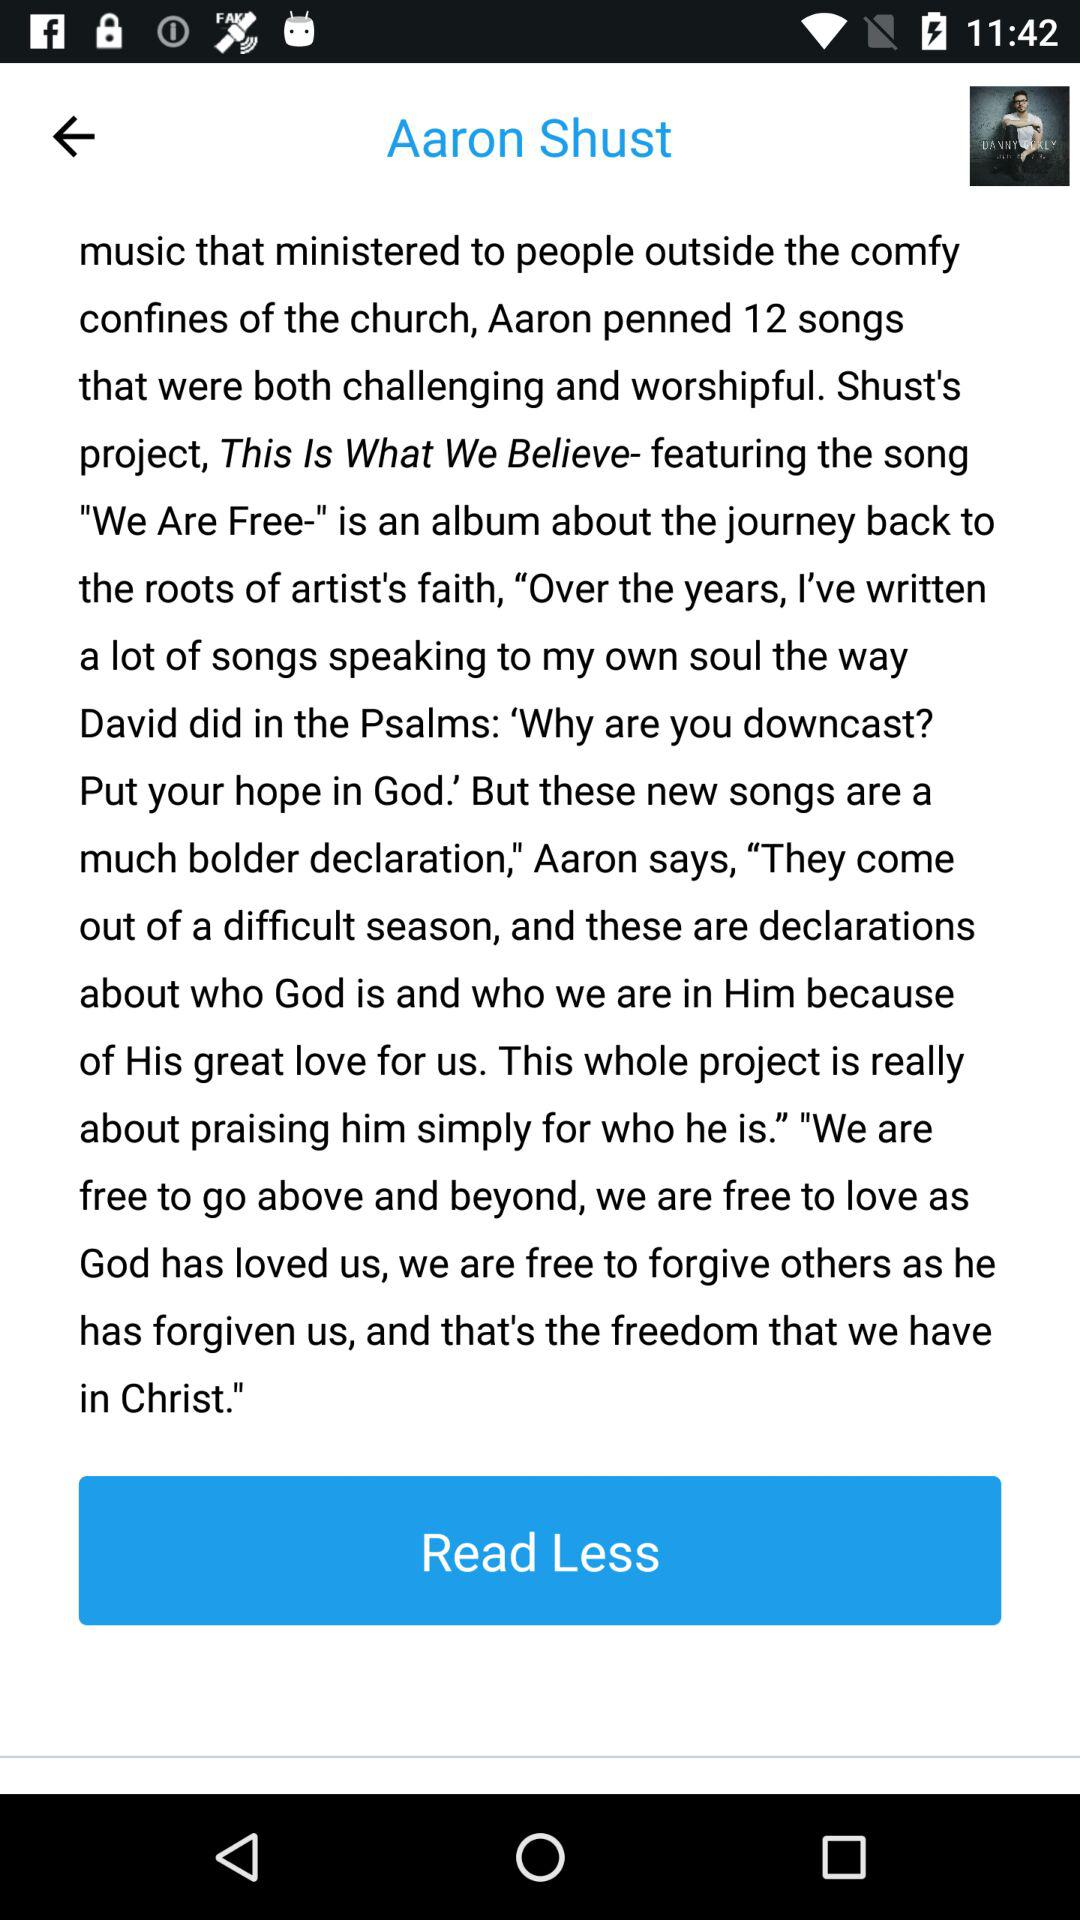What is the name of the artist? The name of the artist is Aaron Shust. 